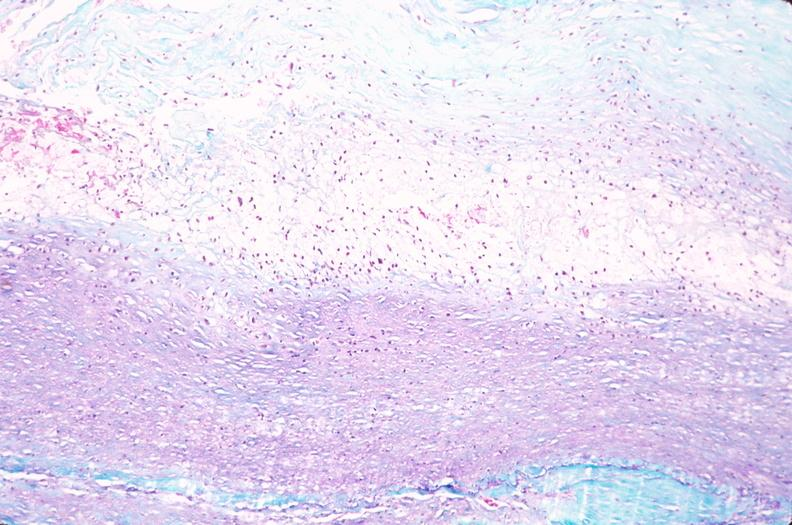what is present?
Answer the question using a single word or phrase. Cardiovascular 